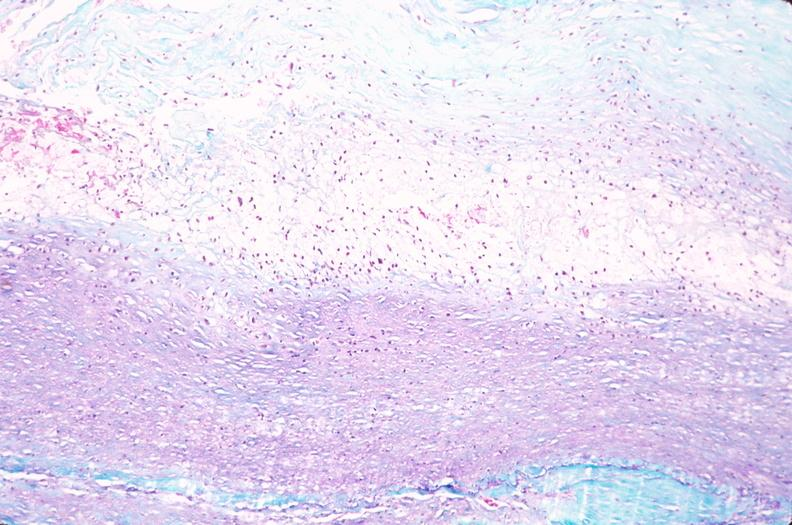what is present?
Answer the question using a single word or phrase. Cardiovascular 